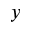<formula> <loc_0><loc_0><loc_500><loc_500>y</formula> 